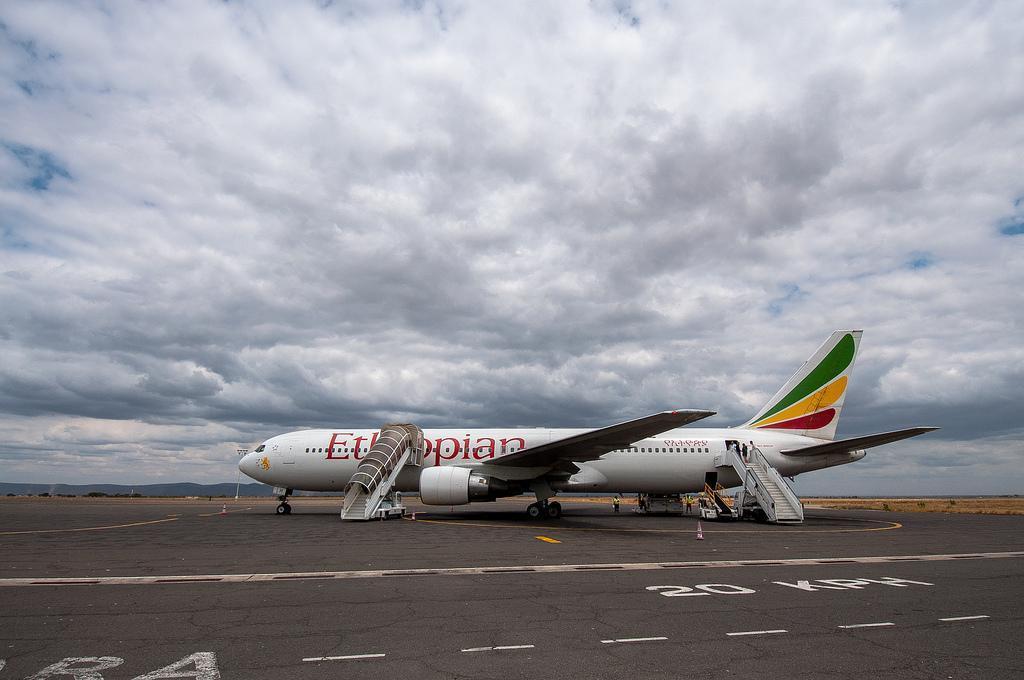How many police have yellow jackets?
Give a very brief answer. 2. How many airplanes are there?
Give a very brief answer. 1. How many colors are on the tail?
Give a very brief answer. 3. How many planes are pictured?
Give a very brief answer. 1. How many staircases are pictured?
Give a very brief answer. 2. How many sets of airplane wheels are visible?
Give a very brief answer. 2. How many planes are in the photo?
Give a very brief answer. 1. How many planes are there?
Give a very brief answer. 1. 